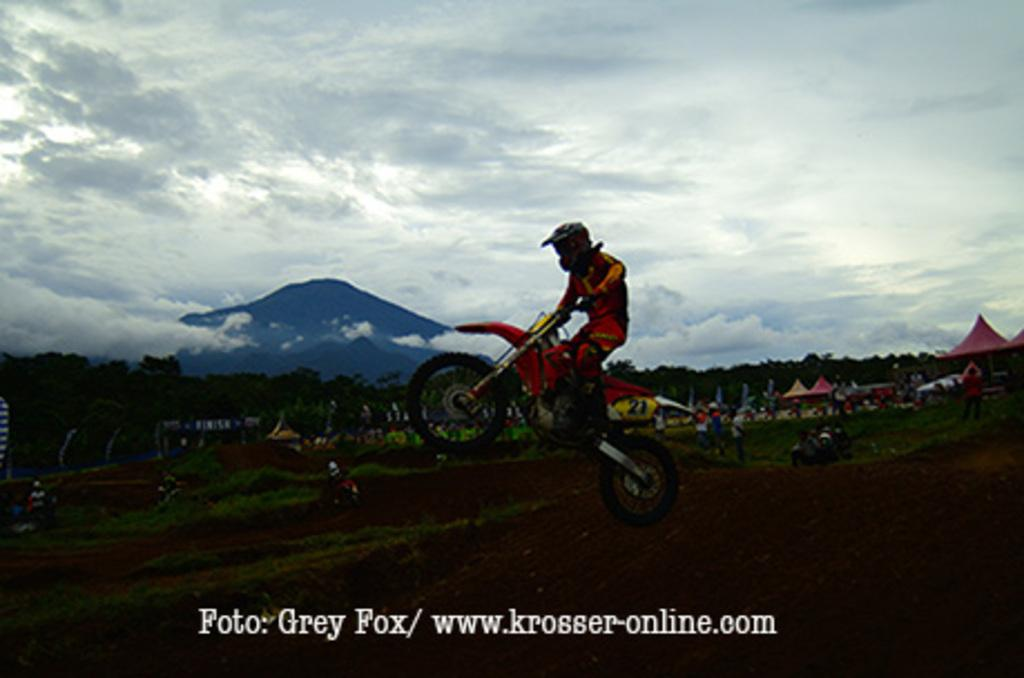What is the man in the image doing? The man is riding a bike in the image. Can you describe the people in the image? There are people in the image, but their specific actions or features are not mentioned in the provided facts. What type of terrain is visible in the image? The ground is covered with grass in the image. What can be seen in the background of the image? There are trees, umbrellas, a mountain, and the sky visible in the background of the image. What type of exchange is taking place between the duck and the mountain in the image? There is no duck present in the image, so no such exchange can be observed. 